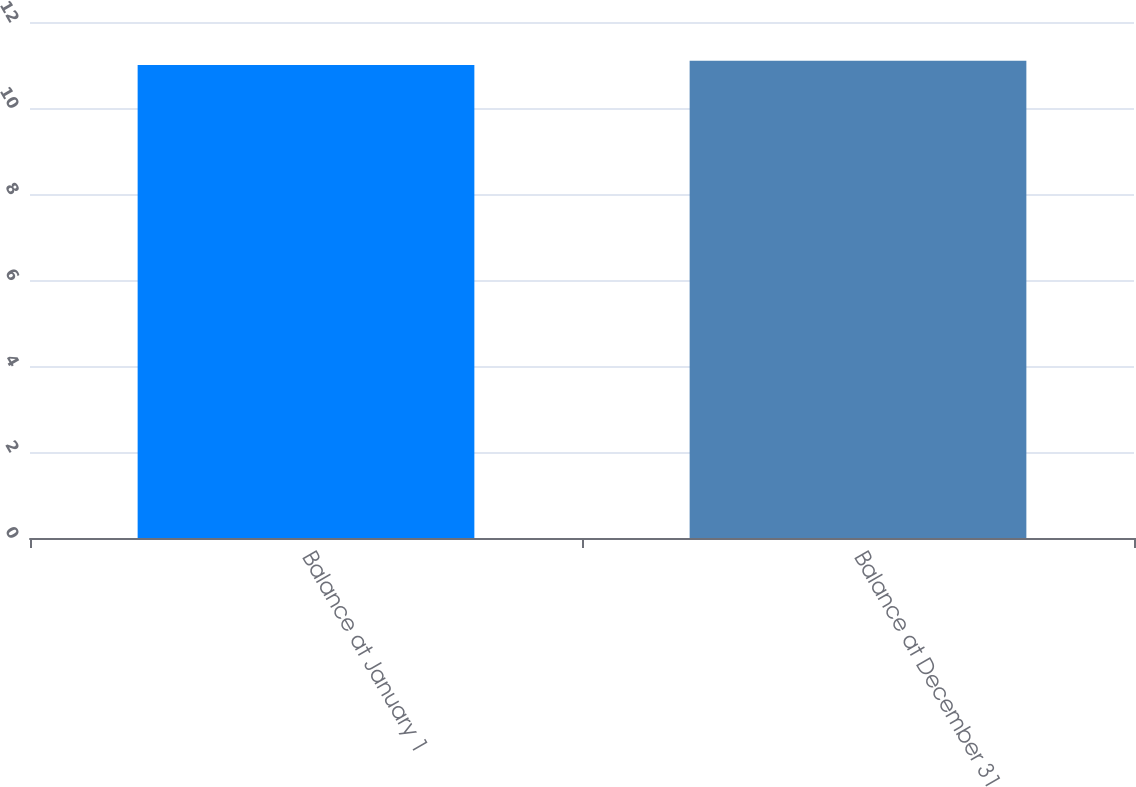Convert chart to OTSL. <chart><loc_0><loc_0><loc_500><loc_500><bar_chart><fcel>Balance at January 1<fcel>Balance at December 31<nl><fcel>11<fcel>11.1<nl></chart> 